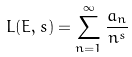Convert formula to latex. <formula><loc_0><loc_0><loc_500><loc_500>L ( E , s ) = \sum _ { n = 1 } ^ { \infty } \frac { a _ { n } } { n ^ { s } }</formula> 